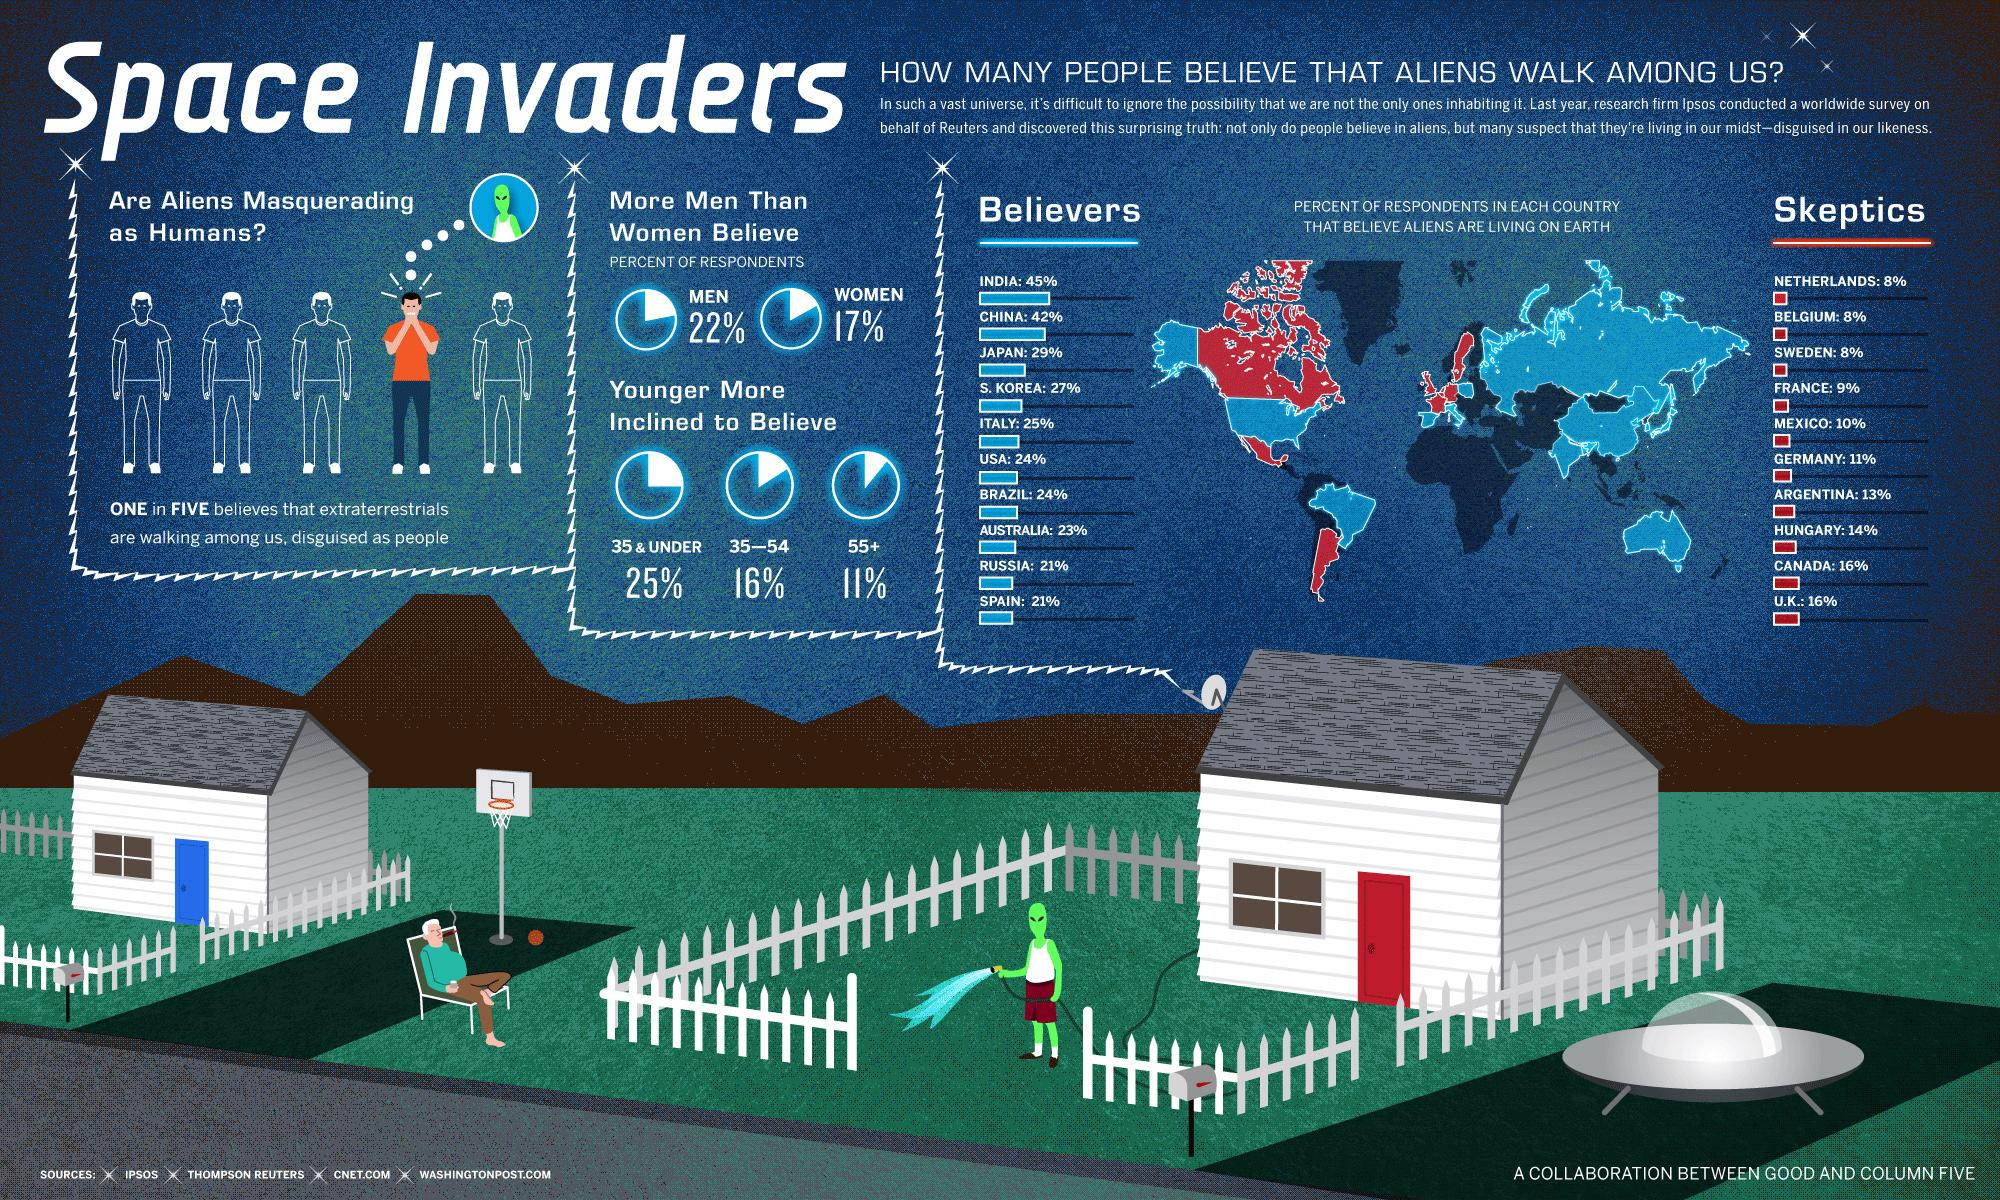Give some essential details in this illustration. Countries such as Russia and Spain have the fewest believers. A recent survey revealed that 11%, 16%, or 25% of people below the age of 35 believe in extraterrestrial life. According to a recent survey, a significant percentage of women, 22%, 17%, or 45%, believe in the existence of space invaders. The percentage of women who believe in space invaders is highest at 45%. According to the percentile numbers, believers of aliens are more prevalent than non-believers. The countries with the highest numbers of skeptics are Canada and the UK. 